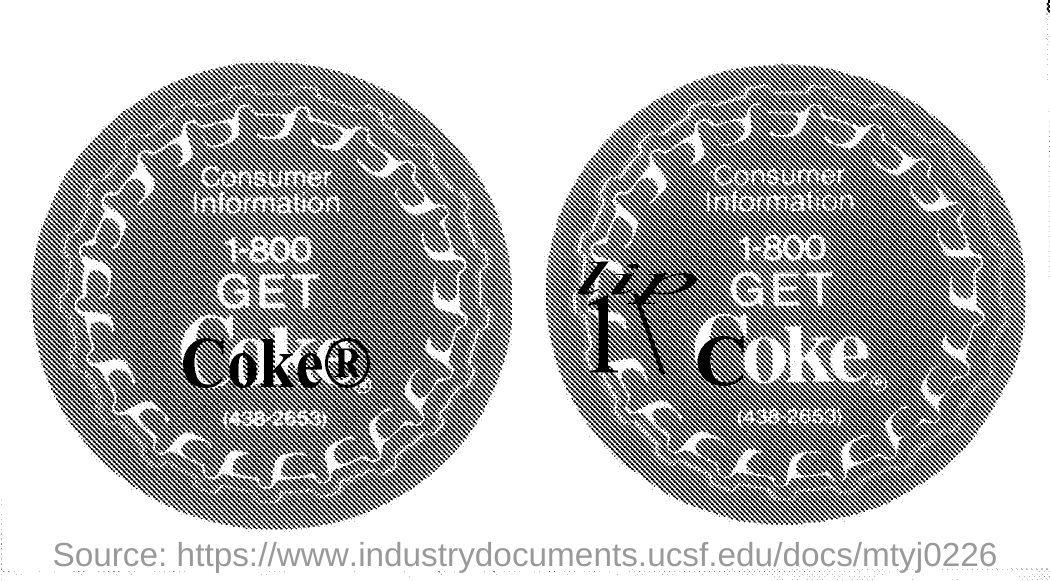What is the word written in bold black in the first picture?
Make the answer very short. Coke ®. 